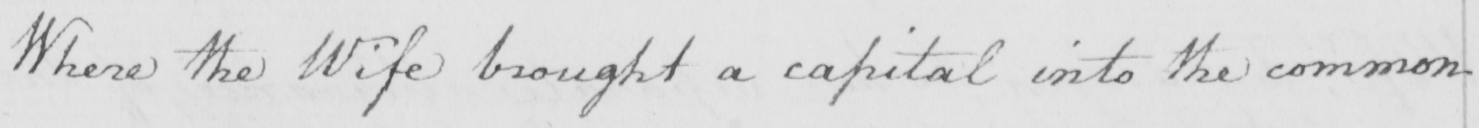Transcribe the text shown in this historical manuscript line. Where the wife brought a capital into the common 